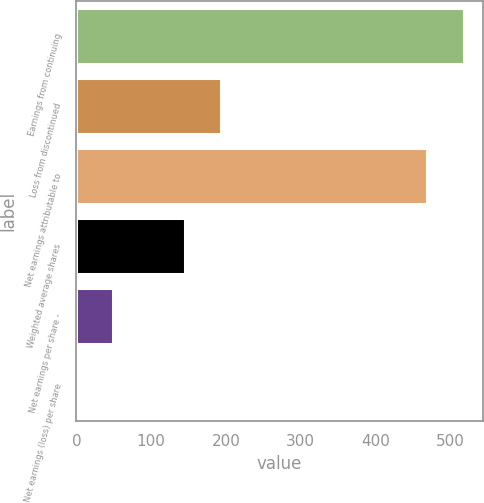Convert chart to OTSL. <chart><loc_0><loc_0><loc_500><loc_500><bar_chart><fcel>Earnings from continuing<fcel>Loss from discontinued<fcel>Net earnings attributable to<fcel>Weighted average shares<fcel>Net earnings per share -<fcel>Net earnings (loss) per share<nl><fcel>517.91<fcel>193.28<fcel>469.6<fcel>144.97<fcel>48.35<fcel>0.04<nl></chart> 